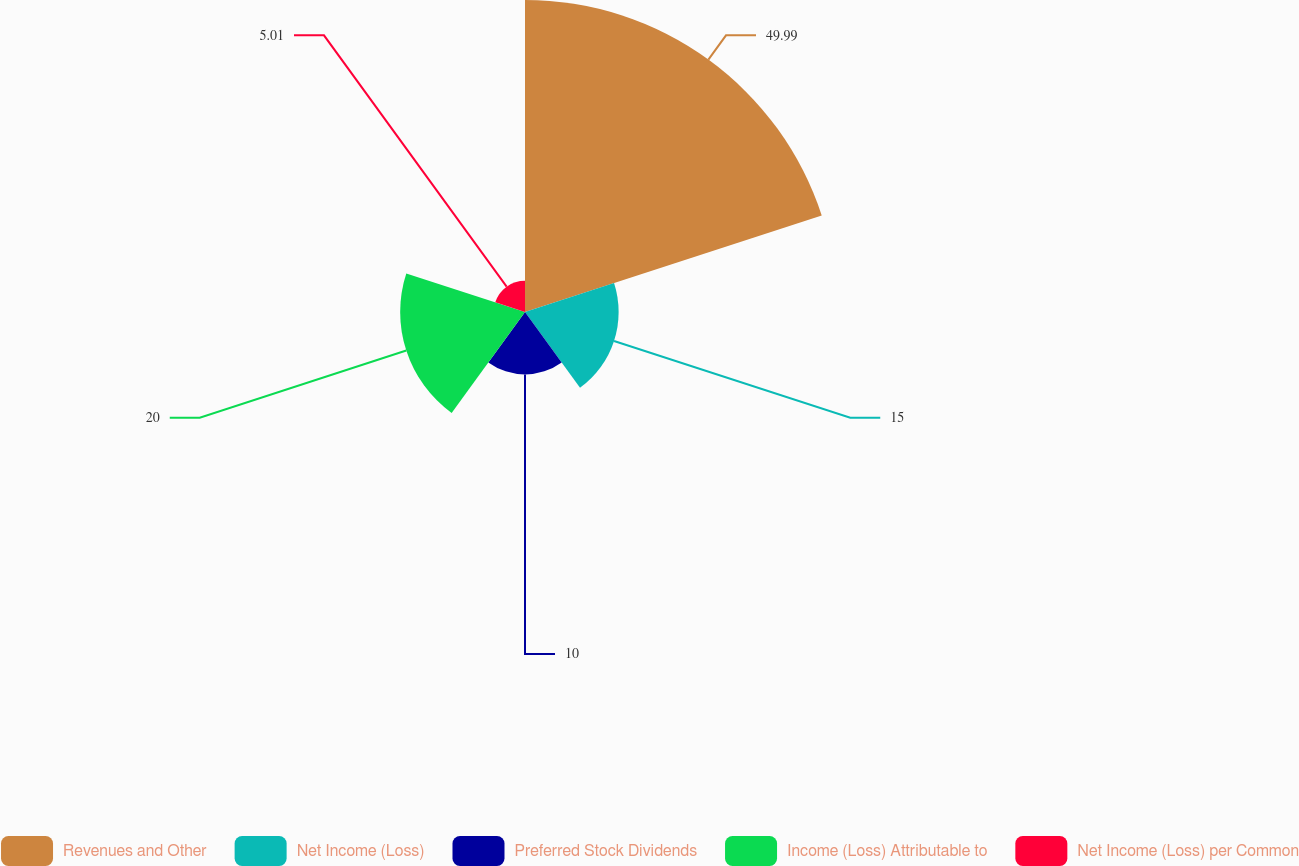Convert chart. <chart><loc_0><loc_0><loc_500><loc_500><pie_chart><fcel>Revenues and Other<fcel>Net Income (Loss)<fcel>Preferred Stock Dividends<fcel>Income (Loss) Attributable to<fcel>Net Income (Loss) per Common<nl><fcel>49.99%<fcel>15.0%<fcel>10.0%<fcel>20.0%<fcel>5.01%<nl></chart> 